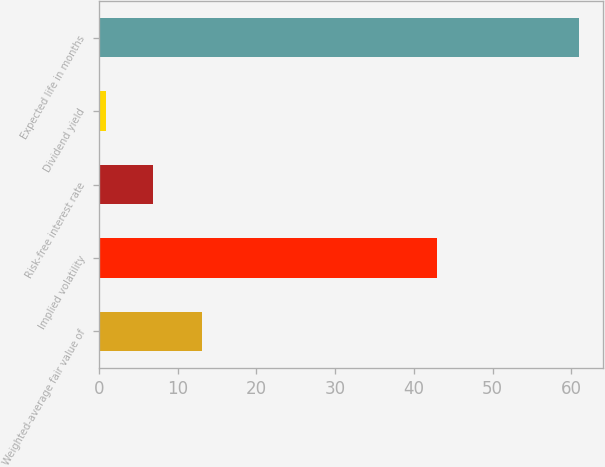<chart> <loc_0><loc_0><loc_500><loc_500><bar_chart><fcel>Weighted-average fair value of<fcel>Implied volatility<fcel>Risk-free interest rate<fcel>Dividend yield<fcel>Expected life in months<nl><fcel>13.04<fcel>43<fcel>6.93<fcel>0.92<fcel>61<nl></chart> 